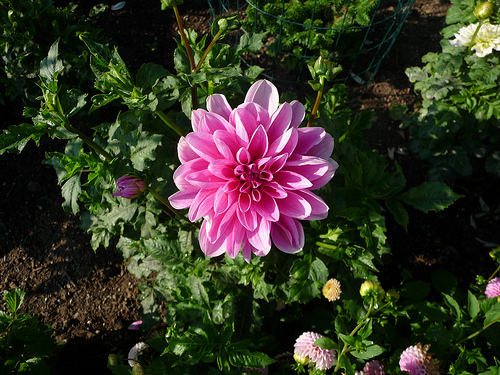<image>
Can you confirm if the plant is above the land? Yes. The plant is positioned above the land in the vertical space, higher up in the scene. 